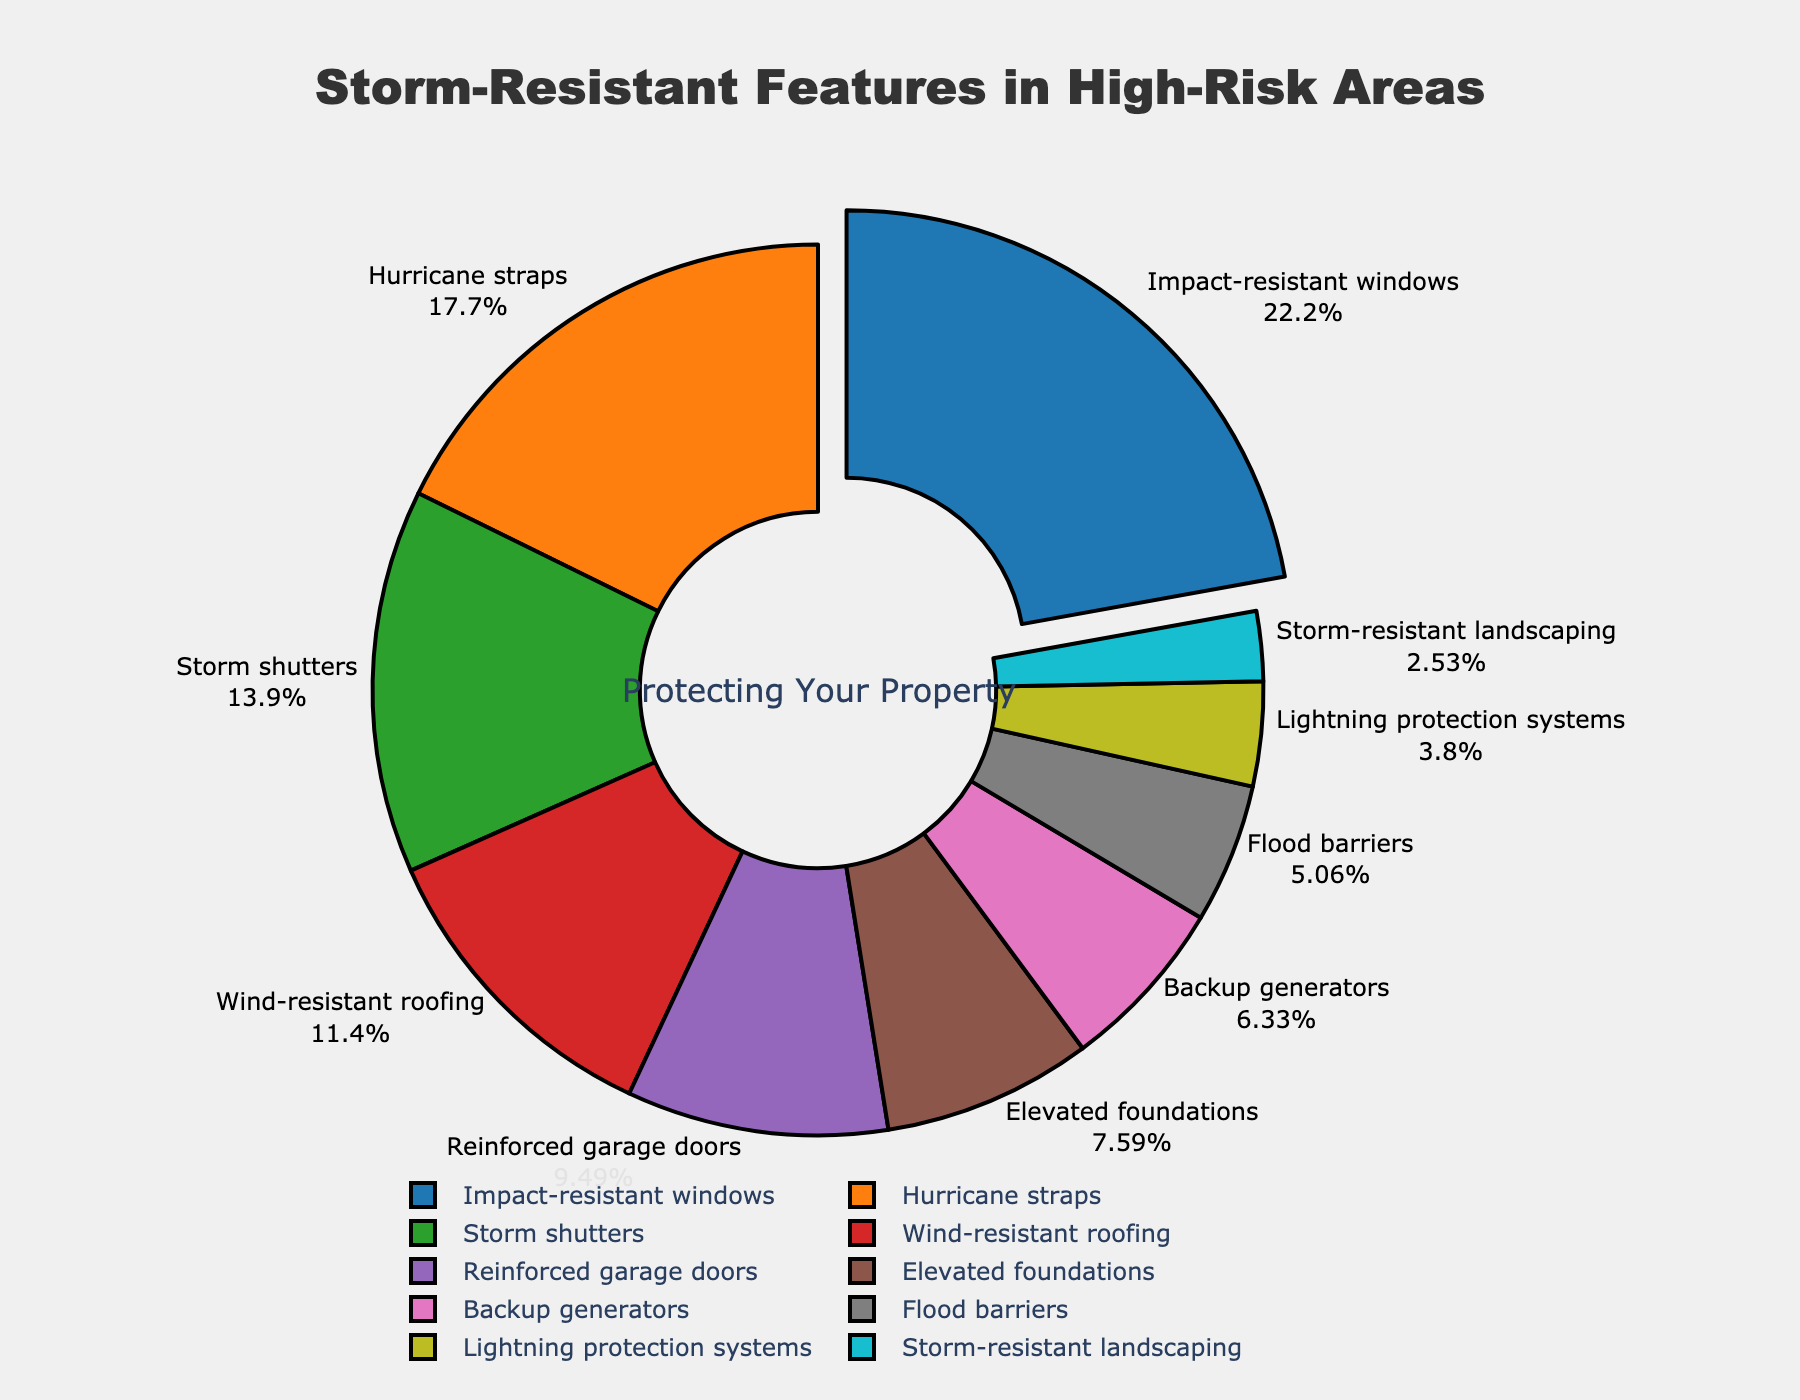What feature has the highest percentage of properties with storm-resistant features in high-risk areas? The figure shows a pie chart with percentages labeled for each feature. The largest segment representing the highest percentage is "Impact-resistant windows" at 35%.
Answer: Impact-resistant windows Which two features have the smallest percentages? The pie chart shows each feature’s percentage. The smallest two segments, representing the lowest percentages, are "Storm-resistant landscaping" at 4% and "Lightning protection systems" at 6%.
Answer: Storm-resistant landscaping and Lightning protection systems What is the combined percentage of properties with Hurricane straps and Storm shutters? The percentages are labelled for each feature. Hurricane straps have 28%, and Storm shutters have 22%. Summing them gives 28% + 22% = 50%.
Answer: 50% Is the percentage of properties with Wind-resistant roofing higher or lower than the percentage with Reinforced garage doors? The pie chart indicates Wind-resistant roofing at 18% and Reinforced garage doors at 15%. 18% is higher than 15%.
Answer: Higher What is the difference in percentage between the highest and lowest features? The highest percentage feature is Impact-resistant windows at 35%, and the lowest is Storm-resistant landscaping at 4%. The difference is 35% - 4% = 31%.
Answer: 31% How many features have a percentage equal to or greater than 15%? From the pie chart, the features with 15% or more are Impact-resistant windows (35%), Hurricane straps (28%), Storm shutters (22%), and Wind-resistant roofing (18%), and Reinforced garage doors (15%). Counting these gives 5 features.
Answer: 5 Which feature is represented by the largest pullout in the pie chart? The largest pullout in the pie chart is the segment that is significantly separated from the others, representing "Impact-resistant windows" at 35%.
Answer: Impact-resistant windows What is the average percentage of the top five features? The top five features by percentage are Impact-resistant windows (35%), Hurricane straps (28%), Storm shutters (22%), Wind-resistant roofing (18%), and Reinforced garage doors (15%). Summing these gives 35% + 28% + 22% + 18% + 15% = 118%. The average is 118% / 5 = 23.6%.
Answer: 23.6% Which feature has a greater percentage, Backup generators or Flood barriers? The pie chart shows Backup generators at 10% and Flood barriers at 8%. Backup generators have a higher percentage than Flood barriers.
Answer: Backup generators What is the percentage difference between Wind-resistant roofing and Hurricane straps? Wind-resistant roofing is 18%, and Hurricane straps are 28%. Thus, the difference is 28% - 18% = 10%.
Answer: 10% 